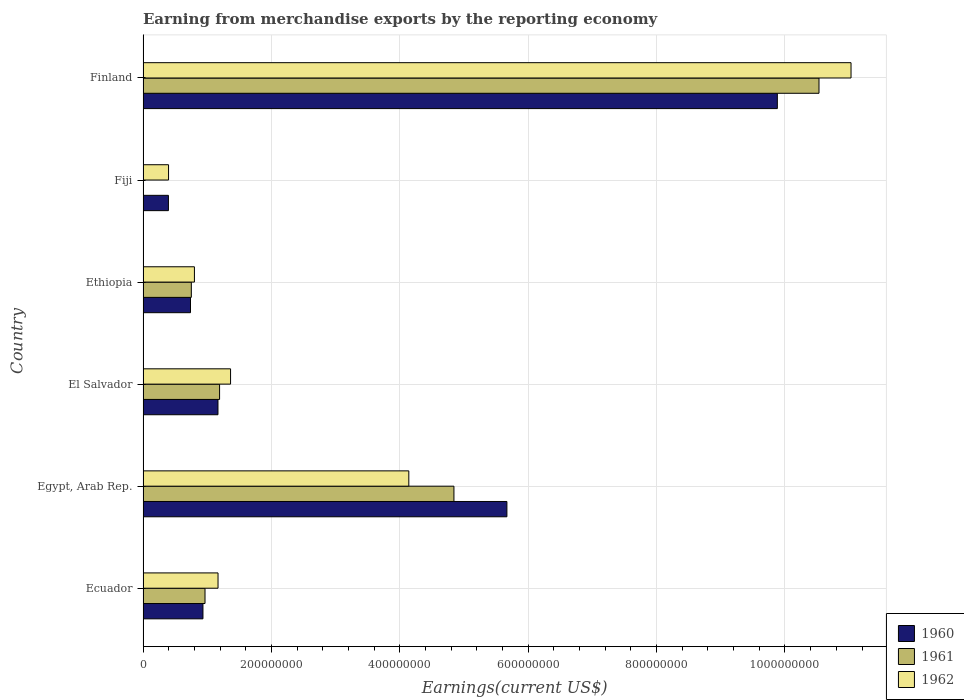How many different coloured bars are there?
Your response must be concise. 3. How many groups of bars are there?
Your answer should be compact. 6. Are the number of bars per tick equal to the number of legend labels?
Provide a succinct answer. Yes. Are the number of bars on each tick of the Y-axis equal?
Your answer should be compact. Yes. How many bars are there on the 1st tick from the top?
Your answer should be very brief. 3. How many bars are there on the 6th tick from the bottom?
Ensure brevity in your answer.  3. What is the label of the 6th group of bars from the top?
Your response must be concise. Ecuador. In how many cases, is the number of bars for a given country not equal to the number of legend labels?
Give a very brief answer. 0. What is the amount earned from merchandise exports in 1960 in Fiji?
Your answer should be very brief. 3.95e+07. Across all countries, what is the maximum amount earned from merchandise exports in 1960?
Offer a very short reply. 9.88e+08. Across all countries, what is the minimum amount earned from merchandise exports in 1961?
Ensure brevity in your answer.  2.00e+05. In which country was the amount earned from merchandise exports in 1960 minimum?
Provide a short and direct response. Fiji. What is the total amount earned from merchandise exports in 1960 in the graph?
Your answer should be very brief. 1.88e+09. What is the difference between the amount earned from merchandise exports in 1960 in El Salvador and that in Ethiopia?
Your response must be concise. 4.28e+07. What is the difference between the amount earned from merchandise exports in 1960 in Egypt, Arab Rep. and the amount earned from merchandise exports in 1962 in Finland?
Provide a succinct answer. -5.36e+08. What is the average amount earned from merchandise exports in 1962 per country?
Provide a short and direct response. 3.15e+08. What is the difference between the amount earned from merchandise exports in 1962 and amount earned from merchandise exports in 1961 in Egypt, Arab Rep.?
Offer a very short reply. -7.03e+07. In how many countries, is the amount earned from merchandise exports in 1961 greater than 800000000 US$?
Provide a succinct answer. 1. What is the ratio of the amount earned from merchandise exports in 1960 in Egypt, Arab Rep. to that in El Salvador?
Your answer should be compact. 4.86. Is the amount earned from merchandise exports in 1961 in Ecuador less than that in El Salvador?
Make the answer very short. Yes. Is the difference between the amount earned from merchandise exports in 1962 in Egypt, Arab Rep. and Fiji greater than the difference between the amount earned from merchandise exports in 1961 in Egypt, Arab Rep. and Fiji?
Ensure brevity in your answer.  No. What is the difference between the highest and the second highest amount earned from merchandise exports in 1962?
Your answer should be very brief. 6.89e+08. What is the difference between the highest and the lowest amount earned from merchandise exports in 1962?
Keep it short and to the point. 1.06e+09. In how many countries, is the amount earned from merchandise exports in 1961 greater than the average amount earned from merchandise exports in 1961 taken over all countries?
Give a very brief answer. 2. What does the 3rd bar from the top in Egypt, Arab Rep. represents?
Make the answer very short. 1960. Is it the case that in every country, the sum of the amount earned from merchandise exports in 1961 and amount earned from merchandise exports in 1962 is greater than the amount earned from merchandise exports in 1960?
Ensure brevity in your answer.  Yes. How many bars are there?
Keep it short and to the point. 18. Are the values on the major ticks of X-axis written in scientific E-notation?
Your answer should be compact. No. Does the graph contain any zero values?
Make the answer very short. No. Where does the legend appear in the graph?
Provide a succinct answer. Bottom right. How many legend labels are there?
Ensure brevity in your answer.  3. What is the title of the graph?
Provide a succinct answer. Earning from merchandise exports by the reporting economy. What is the label or title of the X-axis?
Offer a terse response. Earnings(current US$). What is the Earnings(current US$) of 1960 in Ecuador?
Give a very brief answer. 9.33e+07. What is the Earnings(current US$) of 1961 in Ecuador?
Give a very brief answer. 9.65e+07. What is the Earnings(current US$) in 1962 in Ecuador?
Your response must be concise. 1.17e+08. What is the Earnings(current US$) of 1960 in Egypt, Arab Rep.?
Your response must be concise. 5.67e+08. What is the Earnings(current US$) of 1961 in Egypt, Arab Rep.?
Offer a very short reply. 4.84e+08. What is the Earnings(current US$) of 1962 in Egypt, Arab Rep.?
Offer a very short reply. 4.14e+08. What is the Earnings(current US$) of 1960 in El Salvador?
Make the answer very short. 1.17e+08. What is the Earnings(current US$) of 1961 in El Salvador?
Ensure brevity in your answer.  1.19e+08. What is the Earnings(current US$) of 1962 in El Salvador?
Provide a short and direct response. 1.36e+08. What is the Earnings(current US$) in 1960 in Ethiopia?
Give a very brief answer. 7.39e+07. What is the Earnings(current US$) of 1961 in Ethiopia?
Give a very brief answer. 7.52e+07. What is the Earnings(current US$) in 1962 in Ethiopia?
Your answer should be compact. 8.00e+07. What is the Earnings(current US$) of 1960 in Fiji?
Offer a terse response. 3.95e+07. What is the Earnings(current US$) in 1962 in Fiji?
Make the answer very short. 3.97e+07. What is the Earnings(current US$) of 1960 in Finland?
Provide a short and direct response. 9.88e+08. What is the Earnings(current US$) of 1961 in Finland?
Provide a succinct answer. 1.05e+09. What is the Earnings(current US$) of 1962 in Finland?
Your response must be concise. 1.10e+09. Across all countries, what is the maximum Earnings(current US$) of 1960?
Your answer should be very brief. 9.88e+08. Across all countries, what is the maximum Earnings(current US$) of 1961?
Provide a short and direct response. 1.05e+09. Across all countries, what is the maximum Earnings(current US$) of 1962?
Your answer should be compact. 1.10e+09. Across all countries, what is the minimum Earnings(current US$) in 1960?
Your answer should be compact. 3.95e+07. Across all countries, what is the minimum Earnings(current US$) of 1961?
Give a very brief answer. 2.00e+05. Across all countries, what is the minimum Earnings(current US$) of 1962?
Your answer should be compact. 3.97e+07. What is the total Earnings(current US$) of 1960 in the graph?
Make the answer very short. 1.88e+09. What is the total Earnings(current US$) of 1961 in the graph?
Give a very brief answer. 1.83e+09. What is the total Earnings(current US$) of 1962 in the graph?
Offer a terse response. 1.89e+09. What is the difference between the Earnings(current US$) in 1960 in Ecuador and that in Egypt, Arab Rep.?
Your answer should be compact. -4.74e+08. What is the difference between the Earnings(current US$) of 1961 in Ecuador and that in Egypt, Arab Rep.?
Ensure brevity in your answer.  -3.88e+08. What is the difference between the Earnings(current US$) in 1962 in Ecuador and that in Egypt, Arab Rep.?
Offer a terse response. -2.97e+08. What is the difference between the Earnings(current US$) in 1960 in Ecuador and that in El Salvador?
Your response must be concise. -2.34e+07. What is the difference between the Earnings(current US$) of 1961 in Ecuador and that in El Salvador?
Your response must be concise. -2.27e+07. What is the difference between the Earnings(current US$) in 1962 in Ecuador and that in El Salvador?
Provide a short and direct response. -1.95e+07. What is the difference between the Earnings(current US$) of 1960 in Ecuador and that in Ethiopia?
Make the answer very short. 1.94e+07. What is the difference between the Earnings(current US$) of 1961 in Ecuador and that in Ethiopia?
Provide a succinct answer. 2.13e+07. What is the difference between the Earnings(current US$) of 1962 in Ecuador and that in Ethiopia?
Provide a short and direct response. 3.68e+07. What is the difference between the Earnings(current US$) in 1960 in Ecuador and that in Fiji?
Your response must be concise. 5.38e+07. What is the difference between the Earnings(current US$) in 1961 in Ecuador and that in Fiji?
Offer a very short reply. 9.63e+07. What is the difference between the Earnings(current US$) of 1962 in Ecuador and that in Fiji?
Provide a short and direct response. 7.71e+07. What is the difference between the Earnings(current US$) of 1960 in Ecuador and that in Finland?
Ensure brevity in your answer.  -8.95e+08. What is the difference between the Earnings(current US$) of 1961 in Ecuador and that in Finland?
Offer a very short reply. -9.56e+08. What is the difference between the Earnings(current US$) in 1962 in Ecuador and that in Finland?
Ensure brevity in your answer.  -9.86e+08. What is the difference between the Earnings(current US$) in 1960 in Egypt, Arab Rep. and that in El Salvador?
Provide a short and direct response. 4.50e+08. What is the difference between the Earnings(current US$) of 1961 in Egypt, Arab Rep. and that in El Salvador?
Ensure brevity in your answer.  3.65e+08. What is the difference between the Earnings(current US$) in 1962 in Egypt, Arab Rep. and that in El Salvador?
Your answer should be compact. 2.78e+08. What is the difference between the Earnings(current US$) in 1960 in Egypt, Arab Rep. and that in Ethiopia?
Your response must be concise. 4.93e+08. What is the difference between the Earnings(current US$) of 1961 in Egypt, Arab Rep. and that in Ethiopia?
Keep it short and to the point. 4.09e+08. What is the difference between the Earnings(current US$) of 1962 in Egypt, Arab Rep. and that in Ethiopia?
Keep it short and to the point. 3.34e+08. What is the difference between the Earnings(current US$) of 1960 in Egypt, Arab Rep. and that in Fiji?
Provide a short and direct response. 5.27e+08. What is the difference between the Earnings(current US$) of 1961 in Egypt, Arab Rep. and that in Fiji?
Provide a short and direct response. 4.84e+08. What is the difference between the Earnings(current US$) in 1962 in Egypt, Arab Rep. and that in Fiji?
Offer a very short reply. 3.74e+08. What is the difference between the Earnings(current US$) in 1960 in Egypt, Arab Rep. and that in Finland?
Provide a short and direct response. -4.21e+08. What is the difference between the Earnings(current US$) in 1961 in Egypt, Arab Rep. and that in Finland?
Offer a terse response. -5.69e+08. What is the difference between the Earnings(current US$) in 1962 in Egypt, Arab Rep. and that in Finland?
Give a very brief answer. -6.89e+08. What is the difference between the Earnings(current US$) of 1960 in El Salvador and that in Ethiopia?
Offer a terse response. 4.28e+07. What is the difference between the Earnings(current US$) in 1961 in El Salvador and that in Ethiopia?
Give a very brief answer. 4.40e+07. What is the difference between the Earnings(current US$) in 1962 in El Salvador and that in Ethiopia?
Give a very brief answer. 5.63e+07. What is the difference between the Earnings(current US$) in 1960 in El Salvador and that in Fiji?
Give a very brief answer. 7.72e+07. What is the difference between the Earnings(current US$) of 1961 in El Salvador and that in Fiji?
Offer a terse response. 1.19e+08. What is the difference between the Earnings(current US$) in 1962 in El Salvador and that in Fiji?
Your answer should be compact. 9.66e+07. What is the difference between the Earnings(current US$) of 1960 in El Salvador and that in Finland?
Offer a terse response. -8.71e+08. What is the difference between the Earnings(current US$) of 1961 in El Salvador and that in Finland?
Make the answer very short. -9.34e+08. What is the difference between the Earnings(current US$) in 1962 in El Salvador and that in Finland?
Your answer should be very brief. -9.67e+08. What is the difference between the Earnings(current US$) of 1960 in Ethiopia and that in Fiji?
Provide a succinct answer. 3.44e+07. What is the difference between the Earnings(current US$) of 1961 in Ethiopia and that in Fiji?
Your answer should be very brief. 7.50e+07. What is the difference between the Earnings(current US$) of 1962 in Ethiopia and that in Fiji?
Provide a short and direct response. 4.03e+07. What is the difference between the Earnings(current US$) in 1960 in Ethiopia and that in Finland?
Your answer should be very brief. -9.14e+08. What is the difference between the Earnings(current US$) in 1961 in Ethiopia and that in Finland?
Your answer should be compact. -9.78e+08. What is the difference between the Earnings(current US$) of 1962 in Ethiopia and that in Finland?
Offer a very short reply. -1.02e+09. What is the difference between the Earnings(current US$) of 1960 in Fiji and that in Finland?
Provide a succinct answer. -9.49e+08. What is the difference between the Earnings(current US$) in 1961 in Fiji and that in Finland?
Ensure brevity in your answer.  -1.05e+09. What is the difference between the Earnings(current US$) of 1962 in Fiji and that in Finland?
Keep it short and to the point. -1.06e+09. What is the difference between the Earnings(current US$) in 1960 in Ecuador and the Earnings(current US$) in 1961 in Egypt, Arab Rep.?
Your answer should be very brief. -3.91e+08. What is the difference between the Earnings(current US$) in 1960 in Ecuador and the Earnings(current US$) in 1962 in Egypt, Arab Rep.?
Provide a succinct answer. -3.21e+08. What is the difference between the Earnings(current US$) of 1961 in Ecuador and the Earnings(current US$) of 1962 in Egypt, Arab Rep.?
Provide a succinct answer. -3.18e+08. What is the difference between the Earnings(current US$) of 1960 in Ecuador and the Earnings(current US$) of 1961 in El Salvador?
Give a very brief answer. -2.59e+07. What is the difference between the Earnings(current US$) in 1960 in Ecuador and the Earnings(current US$) in 1962 in El Salvador?
Give a very brief answer. -4.30e+07. What is the difference between the Earnings(current US$) of 1961 in Ecuador and the Earnings(current US$) of 1962 in El Salvador?
Ensure brevity in your answer.  -3.98e+07. What is the difference between the Earnings(current US$) of 1960 in Ecuador and the Earnings(current US$) of 1961 in Ethiopia?
Your answer should be compact. 1.81e+07. What is the difference between the Earnings(current US$) of 1960 in Ecuador and the Earnings(current US$) of 1962 in Ethiopia?
Give a very brief answer. 1.33e+07. What is the difference between the Earnings(current US$) in 1961 in Ecuador and the Earnings(current US$) in 1962 in Ethiopia?
Provide a succinct answer. 1.65e+07. What is the difference between the Earnings(current US$) of 1960 in Ecuador and the Earnings(current US$) of 1961 in Fiji?
Provide a short and direct response. 9.31e+07. What is the difference between the Earnings(current US$) of 1960 in Ecuador and the Earnings(current US$) of 1962 in Fiji?
Ensure brevity in your answer.  5.36e+07. What is the difference between the Earnings(current US$) in 1961 in Ecuador and the Earnings(current US$) in 1962 in Fiji?
Provide a short and direct response. 5.68e+07. What is the difference between the Earnings(current US$) in 1960 in Ecuador and the Earnings(current US$) in 1961 in Finland?
Your answer should be compact. -9.60e+08. What is the difference between the Earnings(current US$) of 1960 in Ecuador and the Earnings(current US$) of 1962 in Finland?
Your answer should be compact. -1.01e+09. What is the difference between the Earnings(current US$) of 1961 in Ecuador and the Earnings(current US$) of 1962 in Finland?
Provide a succinct answer. -1.01e+09. What is the difference between the Earnings(current US$) of 1960 in Egypt, Arab Rep. and the Earnings(current US$) of 1961 in El Salvador?
Offer a very short reply. 4.48e+08. What is the difference between the Earnings(current US$) in 1960 in Egypt, Arab Rep. and the Earnings(current US$) in 1962 in El Salvador?
Make the answer very short. 4.30e+08. What is the difference between the Earnings(current US$) of 1961 in Egypt, Arab Rep. and the Earnings(current US$) of 1962 in El Salvador?
Provide a succinct answer. 3.48e+08. What is the difference between the Earnings(current US$) of 1960 in Egypt, Arab Rep. and the Earnings(current US$) of 1961 in Ethiopia?
Your answer should be very brief. 4.92e+08. What is the difference between the Earnings(current US$) in 1960 in Egypt, Arab Rep. and the Earnings(current US$) in 1962 in Ethiopia?
Provide a succinct answer. 4.87e+08. What is the difference between the Earnings(current US$) of 1961 in Egypt, Arab Rep. and the Earnings(current US$) of 1962 in Ethiopia?
Provide a short and direct response. 4.04e+08. What is the difference between the Earnings(current US$) in 1960 in Egypt, Arab Rep. and the Earnings(current US$) in 1961 in Fiji?
Your response must be concise. 5.67e+08. What is the difference between the Earnings(current US$) in 1960 in Egypt, Arab Rep. and the Earnings(current US$) in 1962 in Fiji?
Provide a short and direct response. 5.27e+08. What is the difference between the Earnings(current US$) of 1961 in Egypt, Arab Rep. and the Earnings(current US$) of 1962 in Fiji?
Provide a succinct answer. 4.45e+08. What is the difference between the Earnings(current US$) in 1960 in Egypt, Arab Rep. and the Earnings(current US$) in 1961 in Finland?
Your response must be concise. -4.86e+08. What is the difference between the Earnings(current US$) in 1960 in Egypt, Arab Rep. and the Earnings(current US$) in 1962 in Finland?
Your answer should be very brief. -5.36e+08. What is the difference between the Earnings(current US$) of 1961 in Egypt, Arab Rep. and the Earnings(current US$) of 1962 in Finland?
Provide a short and direct response. -6.19e+08. What is the difference between the Earnings(current US$) of 1960 in El Salvador and the Earnings(current US$) of 1961 in Ethiopia?
Make the answer very short. 4.15e+07. What is the difference between the Earnings(current US$) in 1960 in El Salvador and the Earnings(current US$) in 1962 in Ethiopia?
Your response must be concise. 3.67e+07. What is the difference between the Earnings(current US$) in 1961 in El Salvador and the Earnings(current US$) in 1962 in Ethiopia?
Your answer should be very brief. 3.92e+07. What is the difference between the Earnings(current US$) of 1960 in El Salvador and the Earnings(current US$) of 1961 in Fiji?
Your answer should be very brief. 1.16e+08. What is the difference between the Earnings(current US$) of 1960 in El Salvador and the Earnings(current US$) of 1962 in Fiji?
Your answer should be very brief. 7.70e+07. What is the difference between the Earnings(current US$) of 1961 in El Salvador and the Earnings(current US$) of 1962 in Fiji?
Give a very brief answer. 7.95e+07. What is the difference between the Earnings(current US$) in 1960 in El Salvador and the Earnings(current US$) in 1961 in Finland?
Keep it short and to the point. -9.36e+08. What is the difference between the Earnings(current US$) in 1960 in El Salvador and the Earnings(current US$) in 1962 in Finland?
Give a very brief answer. -9.86e+08. What is the difference between the Earnings(current US$) in 1961 in El Salvador and the Earnings(current US$) in 1962 in Finland?
Offer a terse response. -9.84e+08. What is the difference between the Earnings(current US$) of 1960 in Ethiopia and the Earnings(current US$) of 1961 in Fiji?
Keep it short and to the point. 7.37e+07. What is the difference between the Earnings(current US$) of 1960 in Ethiopia and the Earnings(current US$) of 1962 in Fiji?
Your answer should be compact. 3.42e+07. What is the difference between the Earnings(current US$) of 1961 in Ethiopia and the Earnings(current US$) of 1962 in Fiji?
Your response must be concise. 3.55e+07. What is the difference between the Earnings(current US$) in 1960 in Ethiopia and the Earnings(current US$) in 1961 in Finland?
Your answer should be very brief. -9.79e+08. What is the difference between the Earnings(current US$) of 1960 in Ethiopia and the Earnings(current US$) of 1962 in Finland?
Offer a very short reply. -1.03e+09. What is the difference between the Earnings(current US$) of 1961 in Ethiopia and the Earnings(current US$) of 1962 in Finland?
Give a very brief answer. -1.03e+09. What is the difference between the Earnings(current US$) in 1960 in Fiji and the Earnings(current US$) in 1961 in Finland?
Keep it short and to the point. -1.01e+09. What is the difference between the Earnings(current US$) in 1960 in Fiji and the Earnings(current US$) in 1962 in Finland?
Your answer should be very brief. -1.06e+09. What is the difference between the Earnings(current US$) in 1961 in Fiji and the Earnings(current US$) in 1962 in Finland?
Make the answer very short. -1.10e+09. What is the average Earnings(current US$) in 1960 per country?
Ensure brevity in your answer.  3.13e+08. What is the average Earnings(current US$) in 1961 per country?
Offer a very short reply. 3.05e+08. What is the average Earnings(current US$) of 1962 per country?
Your answer should be very brief. 3.15e+08. What is the difference between the Earnings(current US$) in 1960 and Earnings(current US$) in 1961 in Ecuador?
Ensure brevity in your answer.  -3.20e+06. What is the difference between the Earnings(current US$) of 1960 and Earnings(current US$) of 1962 in Ecuador?
Offer a terse response. -2.35e+07. What is the difference between the Earnings(current US$) of 1961 and Earnings(current US$) of 1962 in Ecuador?
Your answer should be compact. -2.03e+07. What is the difference between the Earnings(current US$) in 1960 and Earnings(current US$) in 1961 in Egypt, Arab Rep.?
Your answer should be compact. 8.25e+07. What is the difference between the Earnings(current US$) in 1960 and Earnings(current US$) in 1962 in Egypt, Arab Rep.?
Offer a terse response. 1.53e+08. What is the difference between the Earnings(current US$) of 1961 and Earnings(current US$) of 1962 in Egypt, Arab Rep.?
Your answer should be very brief. 7.03e+07. What is the difference between the Earnings(current US$) of 1960 and Earnings(current US$) of 1961 in El Salvador?
Provide a short and direct response. -2.50e+06. What is the difference between the Earnings(current US$) of 1960 and Earnings(current US$) of 1962 in El Salvador?
Keep it short and to the point. -1.96e+07. What is the difference between the Earnings(current US$) of 1961 and Earnings(current US$) of 1962 in El Salvador?
Your answer should be very brief. -1.71e+07. What is the difference between the Earnings(current US$) in 1960 and Earnings(current US$) in 1961 in Ethiopia?
Ensure brevity in your answer.  -1.30e+06. What is the difference between the Earnings(current US$) of 1960 and Earnings(current US$) of 1962 in Ethiopia?
Provide a short and direct response. -6.10e+06. What is the difference between the Earnings(current US$) in 1961 and Earnings(current US$) in 1962 in Ethiopia?
Your response must be concise. -4.80e+06. What is the difference between the Earnings(current US$) in 1960 and Earnings(current US$) in 1961 in Fiji?
Your response must be concise. 3.93e+07. What is the difference between the Earnings(current US$) of 1960 and Earnings(current US$) of 1962 in Fiji?
Your answer should be very brief. -2.00e+05. What is the difference between the Earnings(current US$) in 1961 and Earnings(current US$) in 1962 in Fiji?
Provide a succinct answer. -3.95e+07. What is the difference between the Earnings(current US$) in 1960 and Earnings(current US$) in 1961 in Finland?
Give a very brief answer. -6.49e+07. What is the difference between the Earnings(current US$) of 1960 and Earnings(current US$) of 1962 in Finland?
Provide a succinct answer. -1.15e+08. What is the difference between the Earnings(current US$) in 1961 and Earnings(current US$) in 1962 in Finland?
Your response must be concise. -4.99e+07. What is the ratio of the Earnings(current US$) of 1960 in Ecuador to that in Egypt, Arab Rep.?
Provide a succinct answer. 0.16. What is the ratio of the Earnings(current US$) in 1961 in Ecuador to that in Egypt, Arab Rep.?
Make the answer very short. 0.2. What is the ratio of the Earnings(current US$) in 1962 in Ecuador to that in Egypt, Arab Rep.?
Offer a terse response. 0.28. What is the ratio of the Earnings(current US$) in 1960 in Ecuador to that in El Salvador?
Your answer should be very brief. 0.8. What is the ratio of the Earnings(current US$) in 1961 in Ecuador to that in El Salvador?
Your response must be concise. 0.81. What is the ratio of the Earnings(current US$) of 1962 in Ecuador to that in El Salvador?
Your answer should be very brief. 0.86. What is the ratio of the Earnings(current US$) in 1960 in Ecuador to that in Ethiopia?
Your response must be concise. 1.26. What is the ratio of the Earnings(current US$) of 1961 in Ecuador to that in Ethiopia?
Give a very brief answer. 1.28. What is the ratio of the Earnings(current US$) of 1962 in Ecuador to that in Ethiopia?
Your answer should be compact. 1.46. What is the ratio of the Earnings(current US$) in 1960 in Ecuador to that in Fiji?
Make the answer very short. 2.36. What is the ratio of the Earnings(current US$) of 1961 in Ecuador to that in Fiji?
Your answer should be very brief. 482.5. What is the ratio of the Earnings(current US$) in 1962 in Ecuador to that in Fiji?
Offer a terse response. 2.94. What is the ratio of the Earnings(current US$) in 1960 in Ecuador to that in Finland?
Keep it short and to the point. 0.09. What is the ratio of the Earnings(current US$) in 1961 in Ecuador to that in Finland?
Make the answer very short. 0.09. What is the ratio of the Earnings(current US$) of 1962 in Ecuador to that in Finland?
Keep it short and to the point. 0.11. What is the ratio of the Earnings(current US$) of 1960 in Egypt, Arab Rep. to that in El Salvador?
Offer a very short reply. 4.86. What is the ratio of the Earnings(current US$) of 1961 in Egypt, Arab Rep. to that in El Salvador?
Offer a terse response. 4.06. What is the ratio of the Earnings(current US$) in 1962 in Egypt, Arab Rep. to that in El Salvador?
Ensure brevity in your answer.  3.04. What is the ratio of the Earnings(current US$) in 1960 in Egypt, Arab Rep. to that in Ethiopia?
Your answer should be compact. 7.67. What is the ratio of the Earnings(current US$) of 1961 in Egypt, Arab Rep. to that in Ethiopia?
Ensure brevity in your answer.  6.44. What is the ratio of the Earnings(current US$) of 1962 in Egypt, Arab Rep. to that in Ethiopia?
Provide a succinct answer. 5.17. What is the ratio of the Earnings(current US$) in 1960 in Egypt, Arab Rep. to that in Fiji?
Provide a short and direct response. 14.35. What is the ratio of the Earnings(current US$) in 1961 in Egypt, Arab Rep. to that in Fiji?
Offer a terse response. 2421.5. What is the ratio of the Earnings(current US$) in 1962 in Egypt, Arab Rep. to that in Fiji?
Ensure brevity in your answer.  10.43. What is the ratio of the Earnings(current US$) in 1960 in Egypt, Arab Rep. to that in Finland?
Offer a terse response. 0.57. What is the ratio of the Earnings(current US$) in 1961 in Egypt, Arab Rep. to that in Finland?
Make the answer very short. 0.46. What is the ratio of the Earnings(current US$) of 1962 in Egypt, Arab Rep. to that in Finland?
Make the answer very short. 0.38. What is the ratio of the Earnings(current US$) in 1960 in El Salvador to that in Ethiopia?
Offer a terse response. 1.58. What is the ratio of the Earnings(current US$) of 1961 in El Salvador to that in Ethiopia?
Your answer should be compact. 1.59. What is the ratio of the Earnings(current US$) in 1962 in El Salvador to that in Ethiopia?
Make the answer very short. 1.7. What is the ratio of the Earnings(current US$) in 1960 in El Salvador to that in Fiji?
Offer a terse response. 2.95. What is the ratio of the Earnings(current US$) in 1961 in El Salvador to that in Fiji?
Your answer should be compact. 596. What is the ratio of the Earnings(current US$) in 1962 in El Salvador to that in Fiji?
Your response must be concise. 3.43. What is the ratio of the Earnings(current US$) of 1960 in El Salvador to that in Finland?
Give a very brief answer. 0.12. What is the ratio of the Earnings(current US$) of 1961 in El Salvador to that in Finland?
Your answer should be compact. 0.11. What is the ratio of the Earnings(current US$) of 1962 in El Salvador to that in Finland?
Your answer should be compact. 0.12. What is the ratio of the Earnings(current US$) of 1960 in Ethiopia to that in Fiji?
Offer a terse response. 1.87. What is the ratio of the Earnings(current US$) of 1961 in Ethiopia to that in Fiji?
Your answer should be very brief. 376. What is the ratio of the Earnings(current US$) of 1962 in Ethiopia to that in Fiji?
Offer a very short reply. 2.02. What is the ratio of the Earnings(current US$) of 1960 in Ethiopia to that in Finland?
Your answer should be very brief. 0.07. What is the ratio of the Earnings(current US$) of 1961 in Ethiopia to that in Finland?
Keep it short and to the point. 0.07. What is the ratio of the Earnings(current US$) in 1962 in Ethiopia to that in Finland?
Your response must be concise. 0.07. What is the ratio of the Earnings(current US$) in 1962 in Fiji to that in Finland?
Provide a short and direct response. 0.04. What is the difference between the highest and the second highest Earnings(current US$) of 1960?
Offer a very short reply. 4.21e+08. What is the difference between the highest and the second highest Earnings(current US$) in 1961?
Provide a succinct answer. 5.69e+08. What is the difference between the highest and the second highest Earnings(current US$) of 1962?
Provide a short and direct response. 6.89e+08. What is the difference between the highest and the lowest Earnings(current US$) in 1960?
Keep it short and to the point. 9.49e+08. What is the difference between the highest and the lowest Earnings(current US$) in 1961?
Your answer should be very brief. 1.05e+09. What is the difference between the highest and the lowest Earnings(current US$) in 1962?
Offer a very short reply. 1.06e+09. 